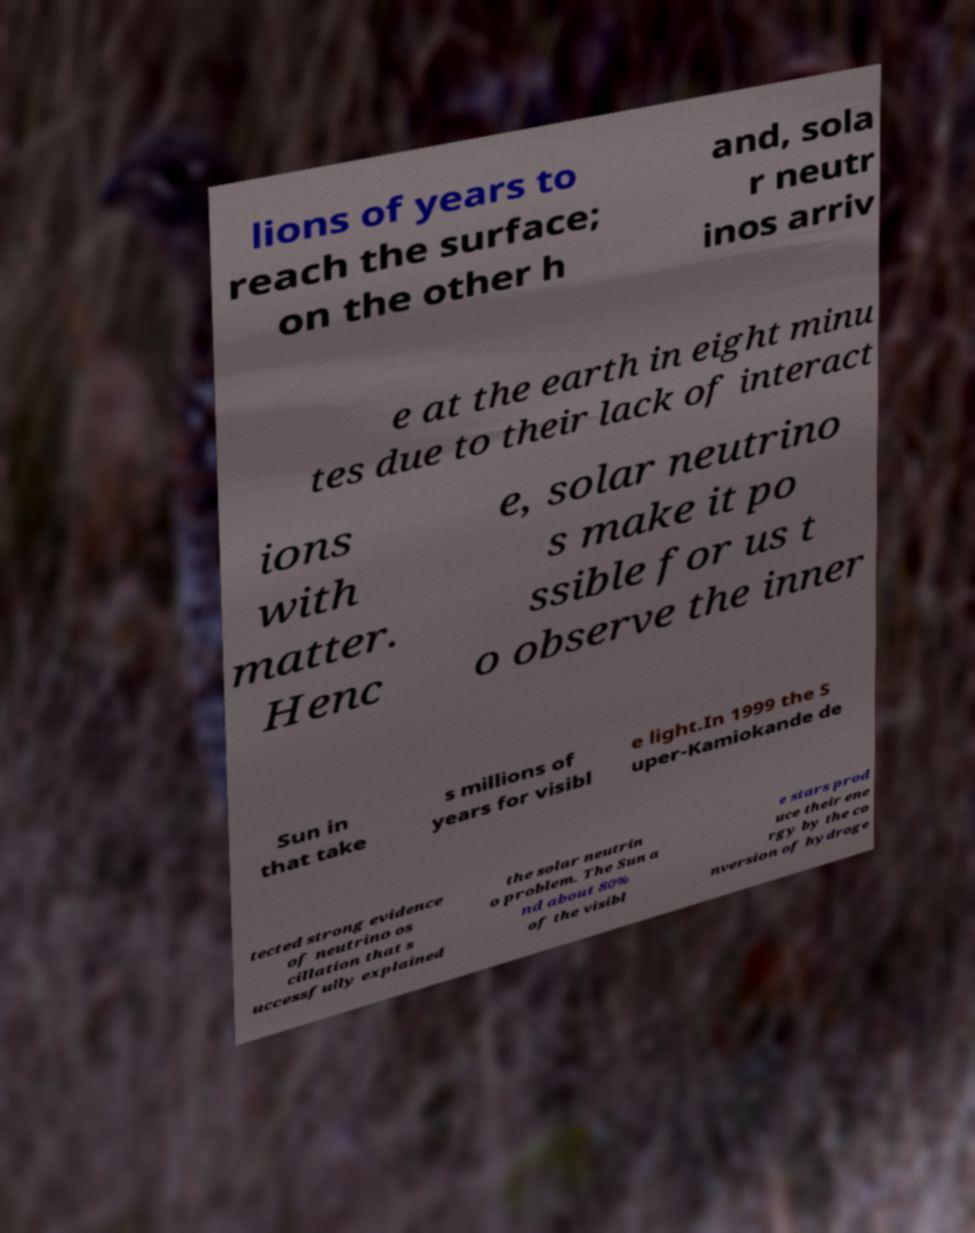Can you accurately transcribe the text from the provided image for me? lions of years to reach the surface; on the other h and, sola r neutr inos arriv e at the earth in eight minu tes due to their lack of interact ions with matter. Henc e, solar neutrino s make it po ssible for us t o observe the inner Sun in that take s millions of years for visibl e light.In 1999 the S uper-Kamiokande de tected strong evidence of neutrino os cillation that s uccessfully explained the solar neutrin o problem. The Sun a nd about 80% of the visibl e stars prod uce their ene rgy by the co nversion of hydroge 